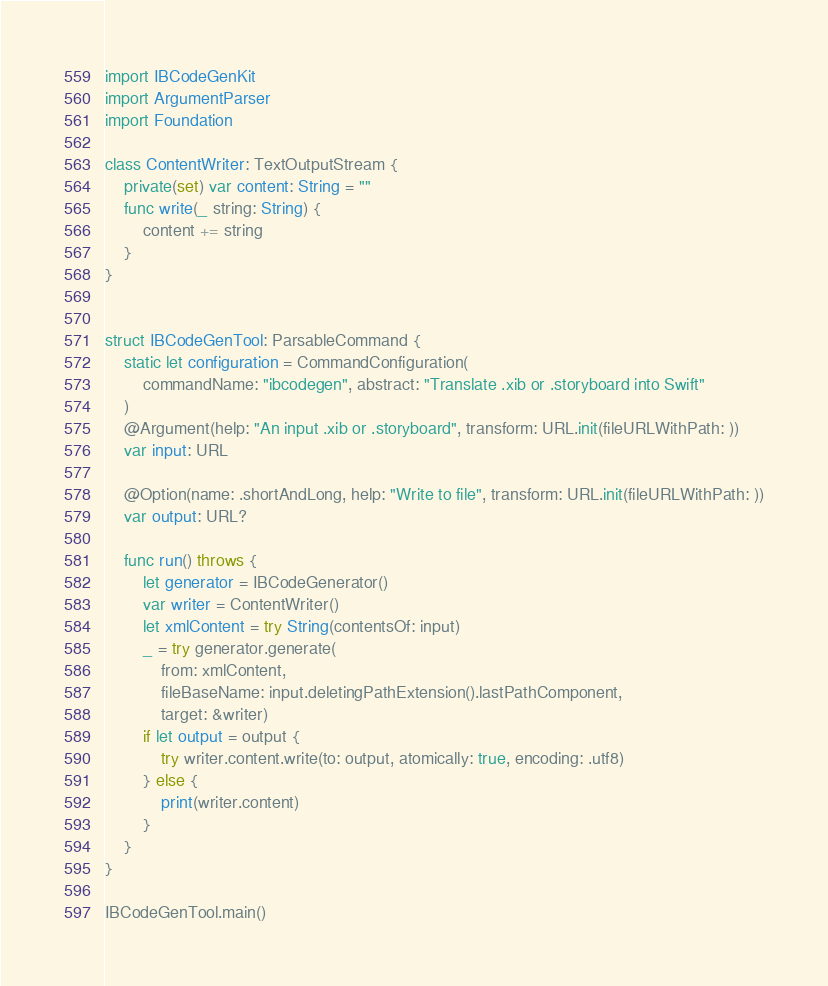<code> <loc_0><loc_0><loc_500><loc_500><_Swift_>import IBCodeGenKit
import ArgumentParser
import Foundation

class ContentWriter: TextOutputStream {
    private(set) var content: String = ""
    func write(_ string: String) {
        content += string
    }
}


struct IBCodeGenTool: ParsableCommand {
    static let configuration = CommandConfiguration(
        commandName: "ibcodegen", abstract: "Translate .xib or .storyboard into Swift"
    )
    @Argument(help: "An input .xib or .storyboard", transform: URL.init(fileURLWithPath: ))
    var input: URL

    @Option(name: .shortAndLong, help: "Write to file", transform: URL.init(fileURLWithPath: ))
    var output: URL?

    func run() throws {
        let generator = IBCodeGenerator()
        var writer = ContentWriter()
        let xmlContent = try String(contentsOf: input)
        _ = try generator.generate(
            from: xmlContent,
            fileBaseName: input.deletingPathExtension().lastPathComponent,
            target: &writer)
        if let output = output {
            try writer.content.write(to: output, atomically: true, encoding: .utf8)
        } else {
            print(writer.content)
        }
    }
}

IBCodeGenTool.main()
</code> 